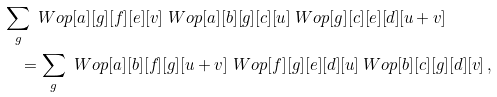Convert formula to latex. <formula><loc_0><loc_0><loc_500><loc_500>& \sum _ { g } \ W o p [ a ] [ g ] [ f ] [ e ] [ v ] \ W o p [ a ] [ b ] [ g ] [ c ] [ u ] \ W o p [ g ] [ c ] [ e ] [ d ] [ u + v ] \\ & \quad = \sum _ { g } \ W o p [ a ] [ b ] [ f ] [ g ] [ u + v ] \ W o p [ f ] [ g ] [ e ] [ d ] [ u ] \ W o p [ b ] [ c ] [ g ] [ d ] [ v ] \, ,</formula> 